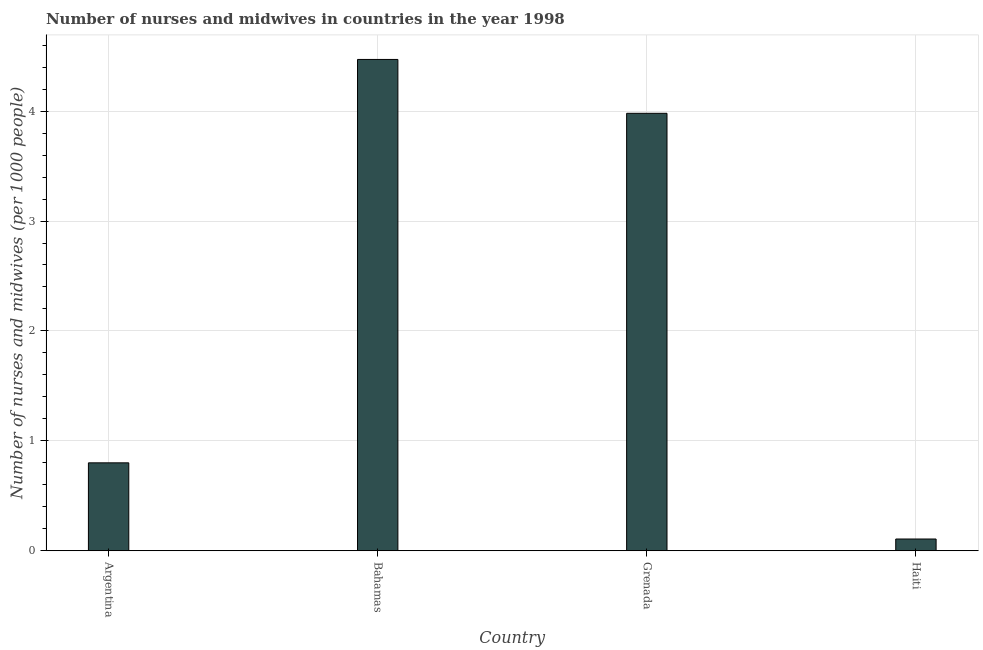Does the graph contain any zero values?
Offer a very short reply. No. What is the title of the graph?
Keep it short and to the point. Number of nurses and midwives in countries in the year 1998. What is the label or title of the X-axis?
Ensure brevity in your answer.  Country. What is the label or title of the Y-axis?
Give a very brief answer. Number of nurses and midwives (per 1000 people). What is the number of nurses and midwives in Bahamas?
Keep it short and to the point. 4.47. Across all countries, what is the maximum number of nurses and midwives?
Provide a succinct answer. 4.47. Across all countries, what is the minimum number of nurses and midwives?
Your answer should be compact. 0.11. In which country was the number of nurses and midwives maximum?
Keep it short and to the point. Bahamas. In which country was the number of nurses and midwives minimum?
Your response must be concise. Haiti. What is the sum of the number of nurses and midwives?
Provide a succinct answer. 9.36. What is the difference between the number of nurses and midwives in Argentina and Bahamas?
Your answer should be compact. -3.67. What is the average number of nurses and midwives per country?
Provide a short and direct response. 2.34. What is the median number of nurses and midwives?
Keep it short and to the point. 2.39. What is the ratio of the number of nurses and midwives in Grenada to that in Haiti?
Offer a terse response. 37.2. What is the difference between the highest and the second highest number of nurses and midwives?
Your answer should be compact. 0.49. What is the difference between the highest and the lowest number of nurses and midwives?
Your answer should be very brief. 4.36. In how many countries, is the number of nurses and midwives greater than the average number of nurses and midwives taken over all countries?
Offer a very short reply. 2. How many bars are there?
Provide a short and direct response. 4. Are all the bars in the graph horizontal?
Ensure brevity in your answer.  No. How many countries are there in the graph?
Make the answer very short. 4. What is the difference between two consecutive major ticks on the Y-axis?
Give a very brief answer. 1. What is the Number of nurses and midwives (per 1000 people) in Argentina?
Your answer should be compact. 0.8. What is the Number of nurses and midwives (per 1000 people) of Bahamas?
Make the answer very short. 4.47. What is the Number of nurses and midwives (per 1000 people) in Grenada?
Your answer should be very brief. 3.98. What is the Number of nurses and midwives (per 1000 people) of Haiti?
Your answer should be very brief. 0.11. What is the difference between the Number of nurses and midwives (per 1000 people) in Argentina and Bahamas?
Give a very brief answer. -3.67. What is the difference between the Number of nurses and midwives (per 1000 people) in Argentina and Grenada?
Make the answer very short. -3.18. What is the difference between the Number of nurses and midwives (per 1000 people) in Argentina and Haiti?
Offer a terse response. 0.69. What is the difference between the Number of nurses and midwives (per 1000 people) in Bahamas and Grenada?
Make the answer very short. 0.49. What is the difference between the Number of nurses and midwives (per 1000 people) in Bahamas and Haiti?
Offer a terse response. 4.36. What is the difference between the Number of nurses and midwives (per 1000 people) in Grenada and Haiti?
Give a very brief answer. 3.87. What is the ratio of the Number of nurses and midwives (per 1000 people) in Argentina to that in Bahamas?
Keep it short and to the point. 0.18. What is the ratio of the Number of nurses and midwives (per 1000 people) in Argentina to that in Grenada?
Give a very brief answer. 0.2. What is the ratio of the Number of nurses and midwives (per 1000 people) in Argentina to that in Haiti?
Your answer should be very brief. 7.48. What is the ratio of the Number of nurses and midwives (per 1000 people) in Bahamas to that in Grenada?
Provide a succinct answer. 1.12. What is the ratio of the Number of nurses and midwives (per 1000 people) in Bahamas to that in Haiti?
Offer a very short reply. 41.78. What is the ratio of the Number of nurses and midwives (per 1000 people) in Grenada to that in Haiti?
Your answer should be compact. 37.2. 